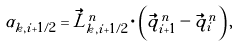Convert formula to latex. <formula><loc_0><loc_0><loc_500><loc_500>\alpha _ { k , i + 1 / 2 } = \vec { L } _ { k , i + 1 / 2 } ^ { n } \cdot \left ( \vec { q } _ { i + 1 } ^ { n } - \vec { q } _ { i } ^ { n } \right ) ,</formula> 